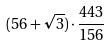<formula> <loc_0><loc_0><loc_500><loc_500>( 5 6 + \sqrt { 3 } ) \cdot \frac { 4 4 3 } { 1 5 6 }</formula> 